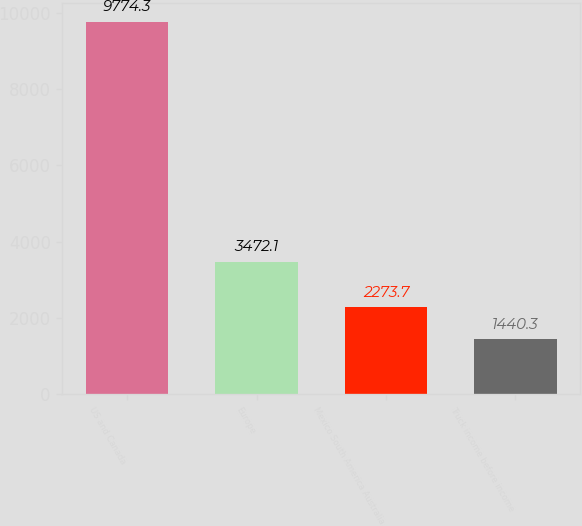<chart> <loc_0><loc_0><loc_500><loc_500><bar_chart><fcel>US and Canada<fcel>Europe<fcel>Mexico South America Australia<fcel>Truck income before income<nl><fcel>9774.3<fcel>3472.1<fcel>2273.7<fcel>1440.3<nl></chart> 